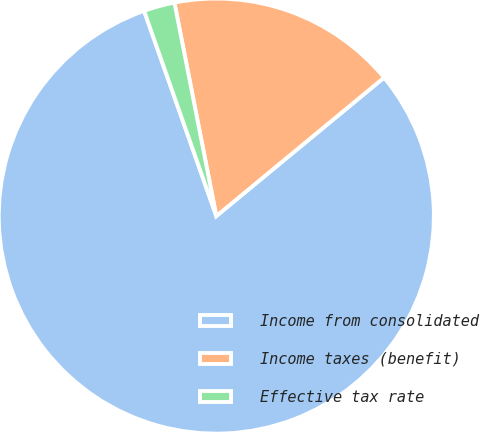Convert chart. <chart><loc_0><loc_0><loc_500><loc_500><pie_chart><fcel>Income from consolidated<fcel>Income taxes (benefit)<fcel>Effective tax rate<nl><fcel>80.59%<fcel>17.1%<fcel>2.3%<nl></chart> 